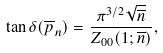<formula> <loc_0><loc_0><loc_500><loc_500>\tan \delta ( \overline { p } _ { n } ) = \frac { \pi ^ { 3 / 2 } \sqrt { \overline { n } } } { Z _ { 0 0 } ( 1 ; \overline { n } ) } ,</formula> 